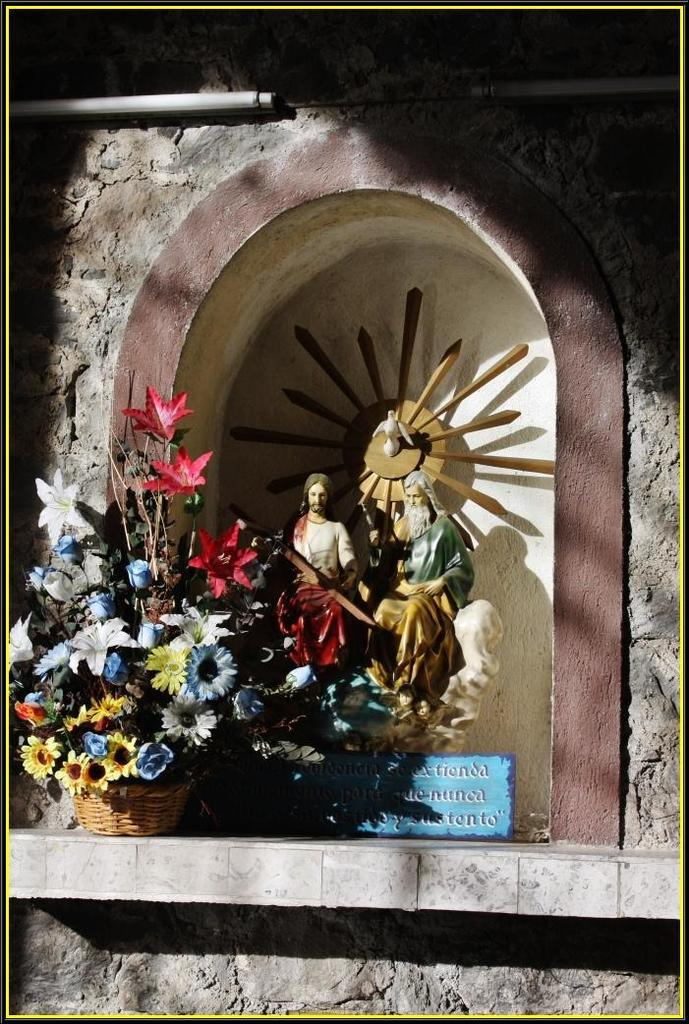What type of objects can be seen in the image? There are statues, a board, a flower bouquet, a basket, and lights visible in the image. What is the purpose of the board in the image? The purpose of the board in the image is not specified, but it could be used for displaying information or as a decorative element. What is placed inside the basket in the image? The contents of the basket are not visible in the image, so it cannot be determined what is inside. What is the background of the image made of? There is a wall in the image, which suggests that the background is made of a solid material, such as brick or concrete. Can you see any waves in the image? There are no waves present in the image; it features statues, a board, a flower bouquet, a basket, and lights. What type of jam is being served with the flower bouquet in the image? There is no jam present in the image; it features statues, a board, a flower bouquet, a basket, and lights. 